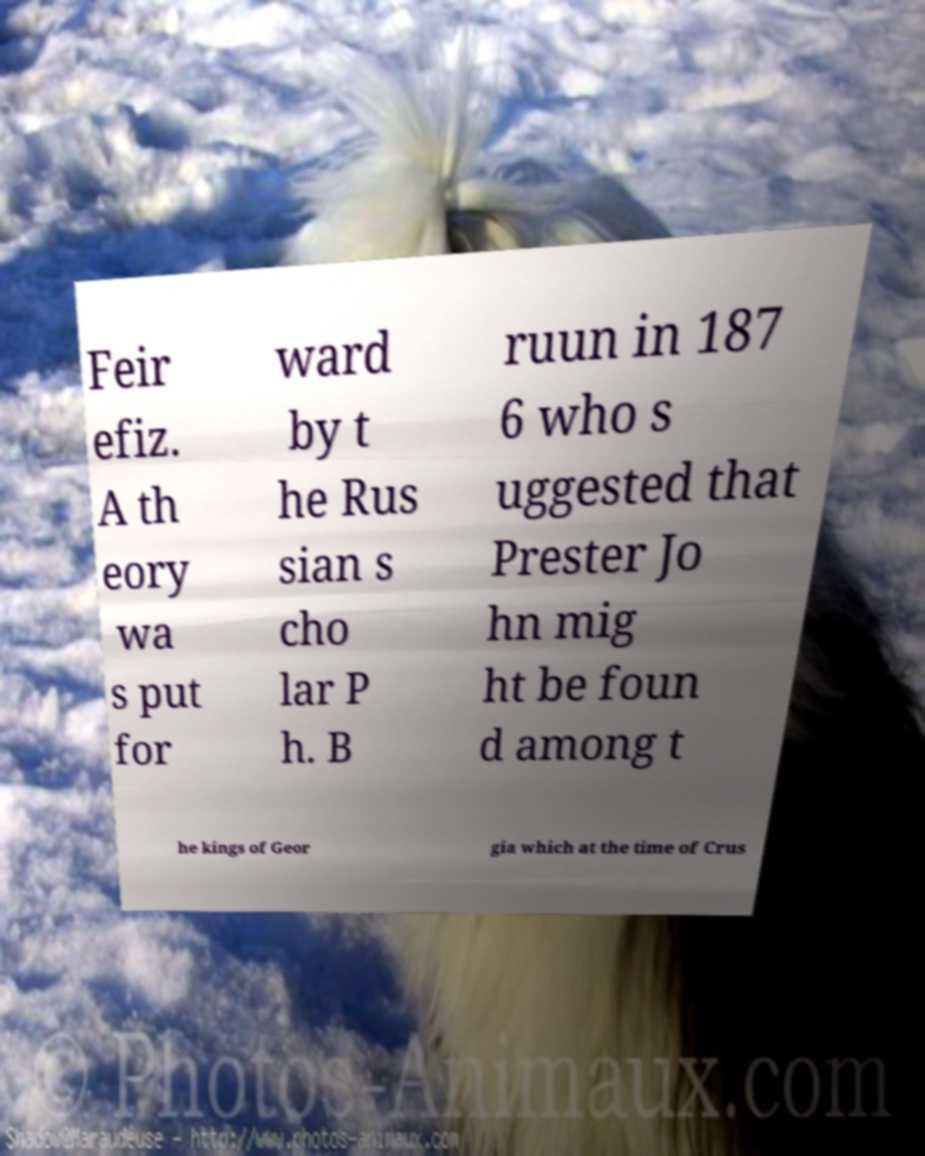What messages or text are displayed in this image? I need them in a readable, typed format. Feir efiz. A th eory wa s put for ward by t he Rus sian s cho lar P h. B ruun in 187 6 who s uggested that Prester Jo hn mig ht be foun d among t he kings of Geor gia which at the time of Crus 